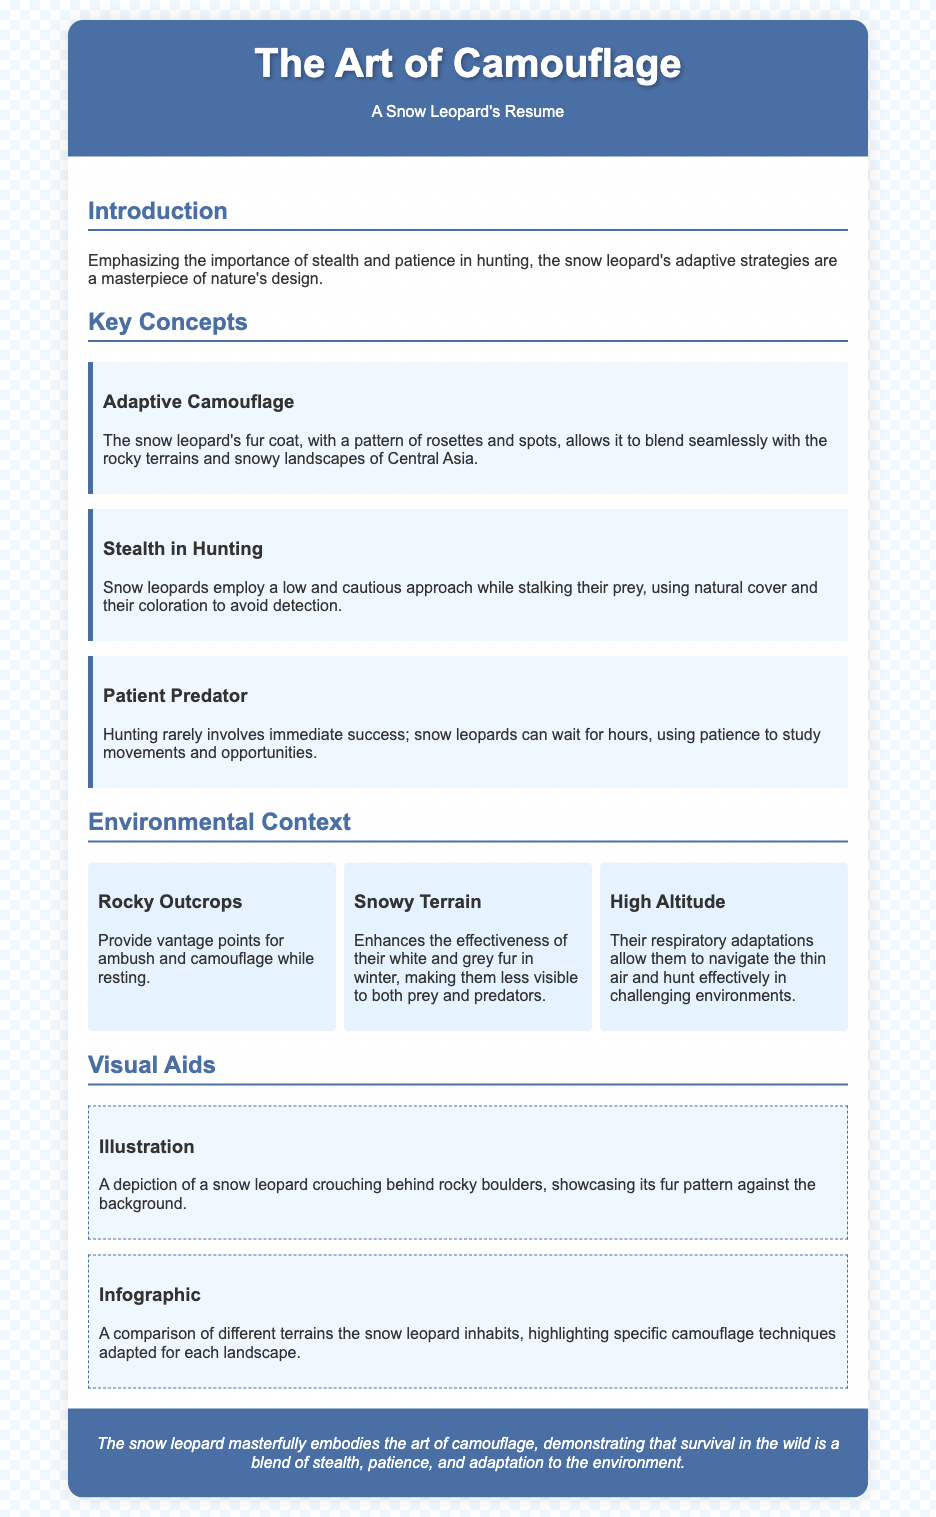what is the title of the document? The title of the document is displayed prominently at the top of the resume, specifically in the header section.
Answer: The Art of Camouflage who is the subject of the resume? The document introduces the main subject within the context of adaptive strategies in hunting, clearly stated in the title.
Answer: Snow Leopard what is the first key concept listed? The first key concept is highlighted in a separate section dedicated to key principles related to the document's theme.
Answer: Adaptive Camouflage how long can snow leopards wait while hunting? The document emphasizes the patience of snow leopards in hunting, specifying their typical behavior regarding this aspect.
Answer: Hours what enhances the effectiveness of a snow leopard's camouflage in winter? This aspect relates to their environmental adaptation mentioned in the landscape section, explaining a specific factor that aids in camouflage.
Answer: Snowy Terrain how many landscape items are described? The number of landscape items is derived from the content sections detailing the different environments snow leopards inhabit.
Answer: Three what is one illustration topic mentioned? The visual aids section lists specific illustrations that depict characteristics of the snow leopard concerning its habitat and behavior.
Answer: Crouching behind rocky boulders what is the main focus of the document? The overall theme of the resume is about the snow leopard's specialized techniques and adaptations in the wild, which is reflected throughout the content.
Answer: The art of camouflage 